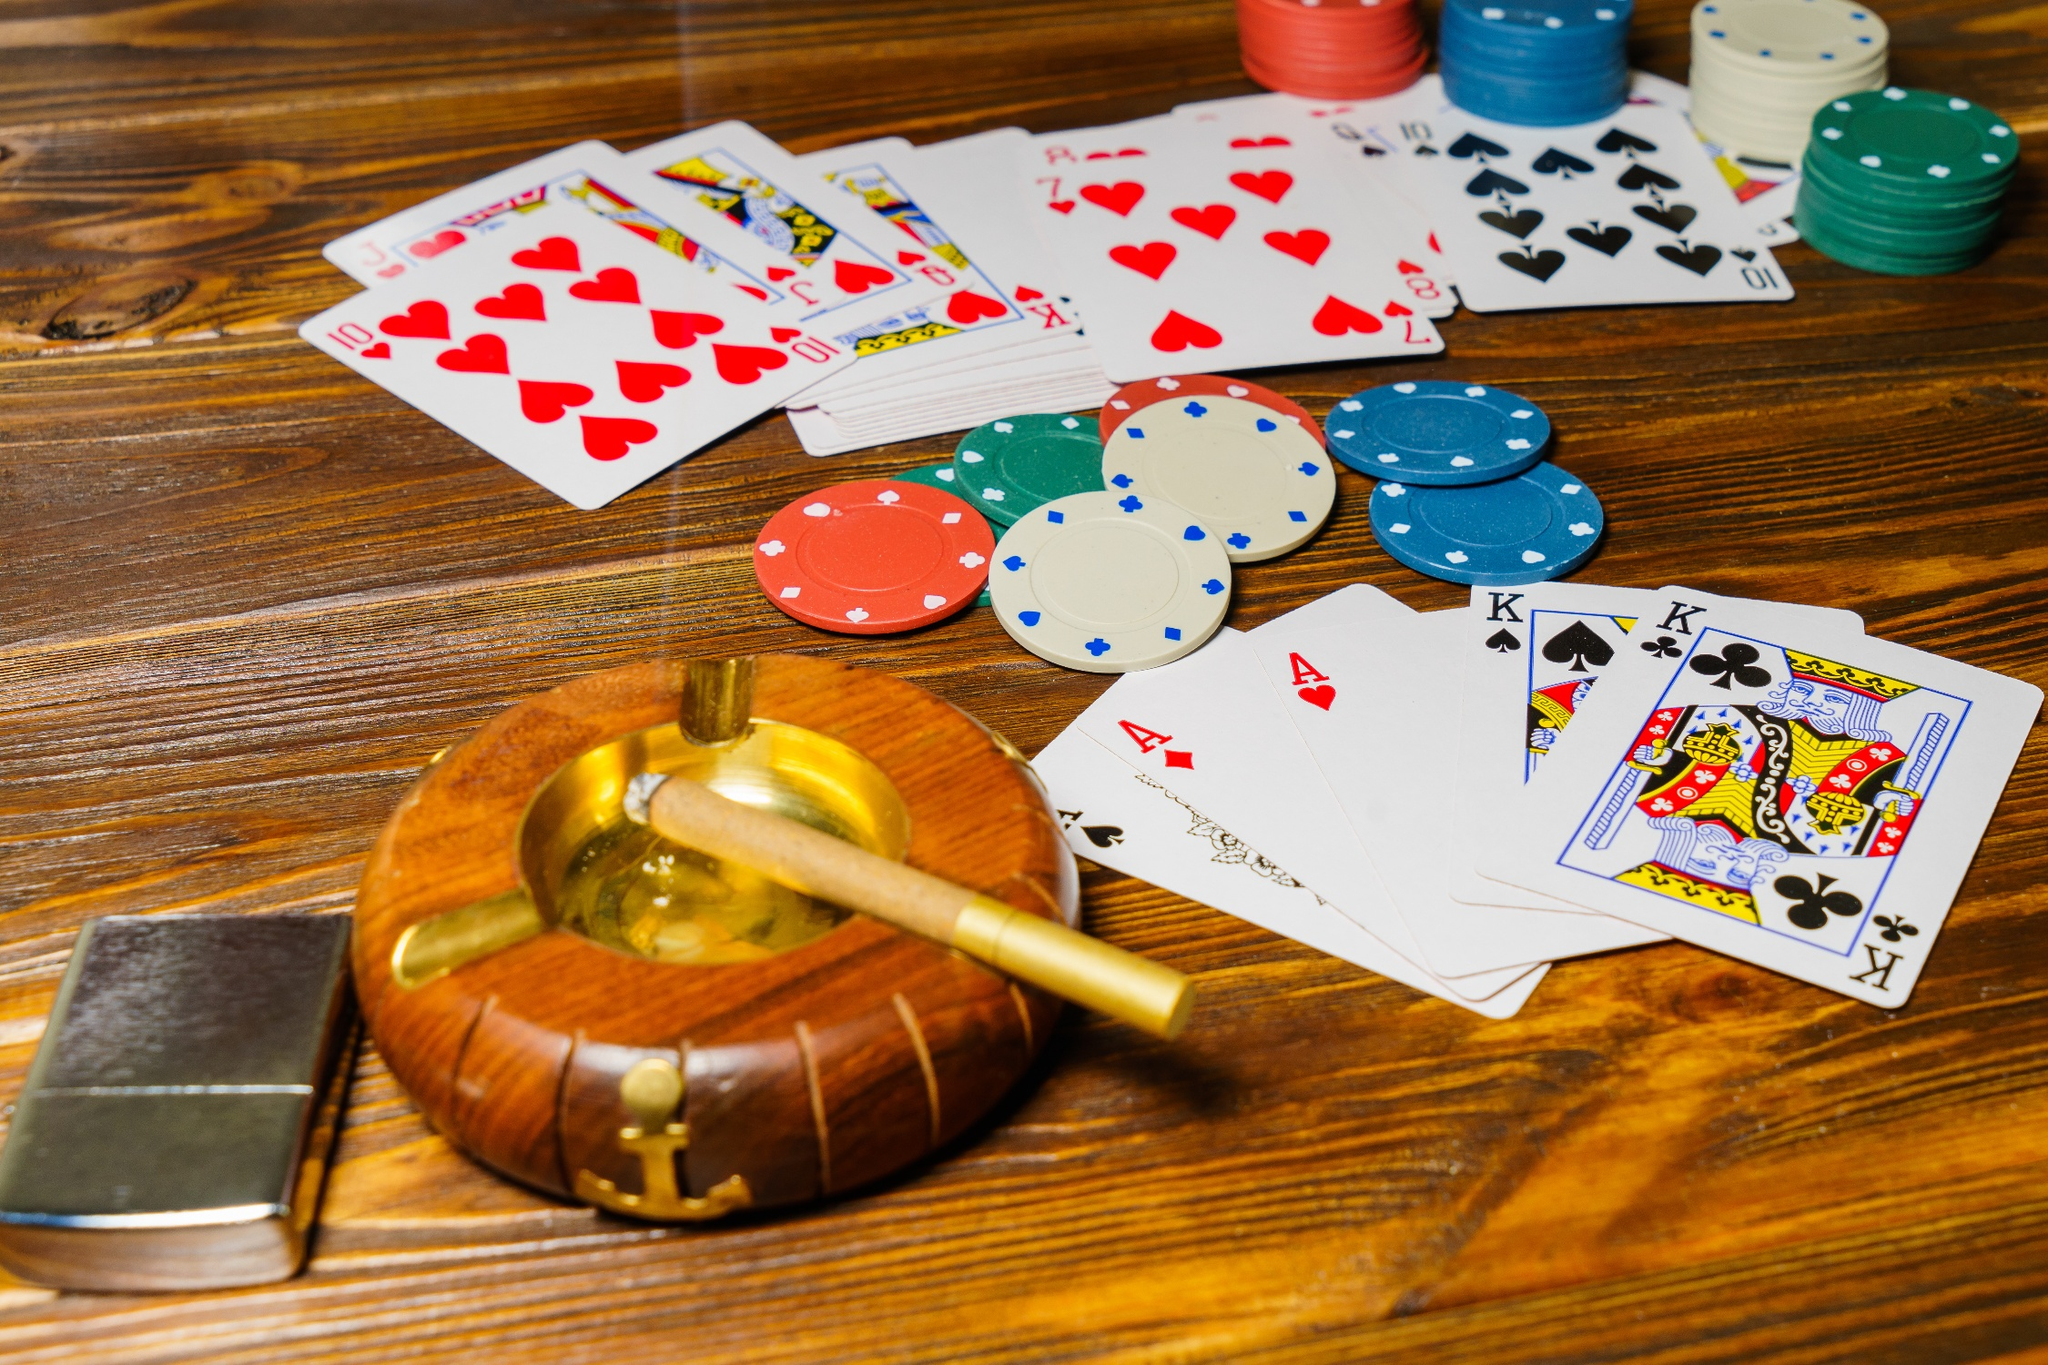What kind of atmosphere does the image evoke? The image evokes an atmosphere of intense concentration, strategy, and sophistication. The carefully stacked poker chips and laid-out cards suggest a keen focus on the game, while the presence of a cigar in the wooden ashtray adds a touch of retro elegance and tension. The warm, rich tones of the wooden table add to the overall feeling of a classic, high-stakes poker night. Imagine the poker game is happening in a 1920s speakeasy. What would the scene be like? In a 1920s speakeasy, the poker game takes on a clandestine and glamorous edge. The dimly lit room, hidden behind a secret door in a nondescript building, is filled with the low murmur of conversations and the clinking of glasses. Jazz music wafts through the air as sharply dressed gentlemen and flapper girls gather around the table. The cigar smoke mingles with the scent of whiskey, heightening the secretive atmosphere. The stakes are high, and every player's face is a mask of cool intensity. This hidden world, shielded from the Prohibition agents, is a sanctuary for game, risk, and revelry. 